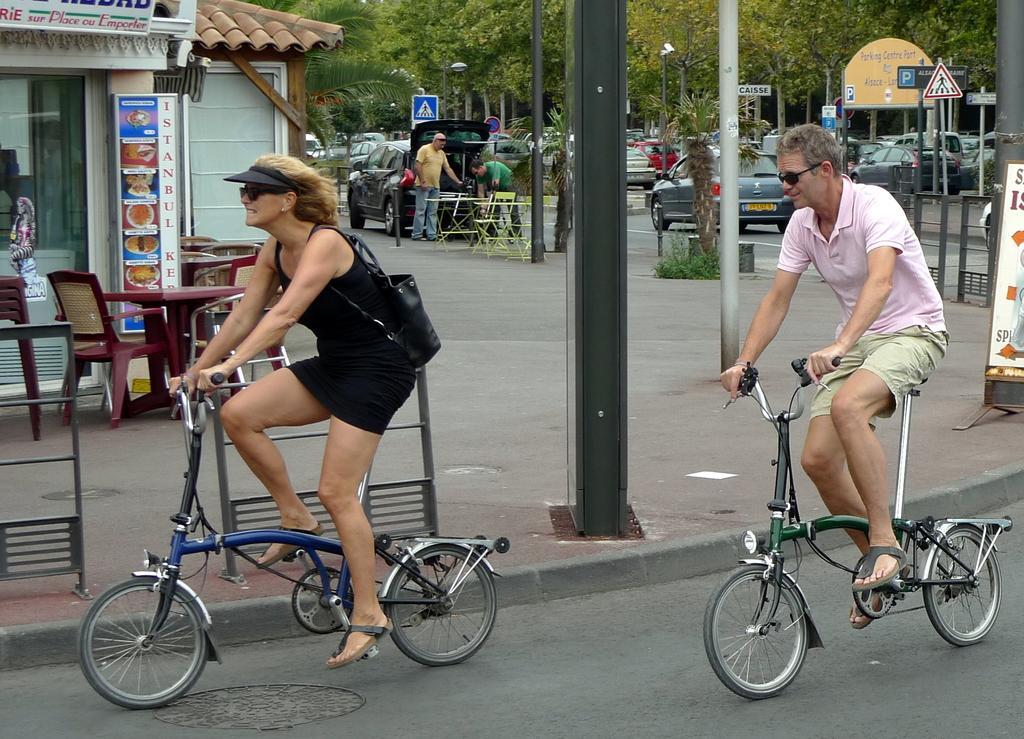Describe this image in one or two sentences. There are two people cycling a bicycle. one is a woman and the other guy is a man. There are poles and trees here. In the background we can see a car and people and a house with tables and chairs in front of it. 